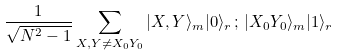Convert formula to latex. <formula><loc_0><loc_0><loc_500><loc_500>\frac { 1 } { \sqrt { N ^ { 2 } - 1 } } \sum _ { X , Y \neq X _ { 0 } Y _ { 0 } } | X , Y \rangle _ { m } | 0 \rangle _ { r } \, ; \, | X _ { 0 } Y _ { 0 } \rangle _ { m } | 1 \rangle _ { r }</formula> 